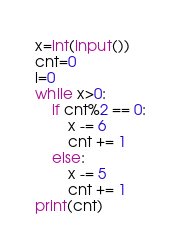Convert code to text. <code><loc_0><loc_0><loc_500><loc_500><_Python_>x=int(input())
cnt=0
i=0
while x>0:
    if cnt%2 == 0:
        x -= 6
        cnt += 1
    else:
        x -= 5
        cnt += 1
print(cnt)</code> 